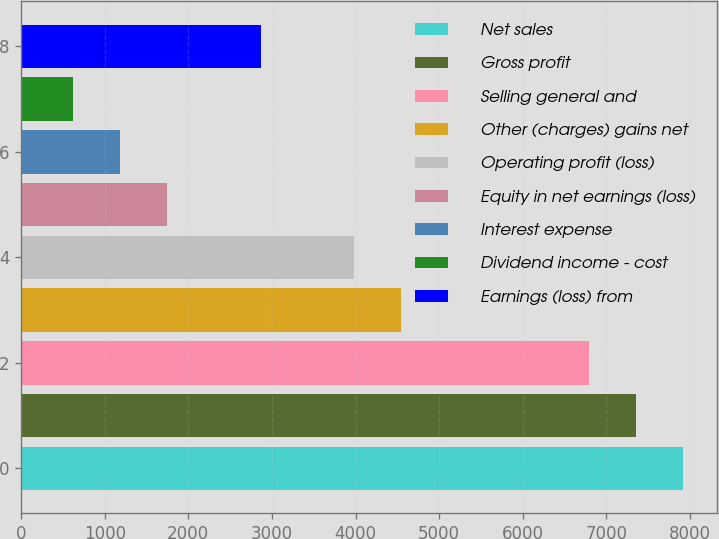<chart> <loc_0><loc_0><loc_500><loc_500><bar_chart><fcel>Net sales<fcel>Gross profit<fcel>Selling general and<fcel>Other (charges) gains net<fcel>Operating profit (loss)<fcel>Equity in net earnings (loss)<fcel>Interest expense<fcel>Dividend income - cost<fcel>Earnings (loss) from<nl><fcel>7922.4<fcel>7360.3<fcel>6798.2<fcel>4549.8<fcel>3987.7<fcel>1739.3<fcel>1177.2<fcel>615.1<fcel>2863.5<nl></chart> 